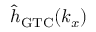<formula> <loc_0><loc_0><loc_500><loc_500>{ \hat { h } } _ { G T C } ( k _ { x } )</formula> 